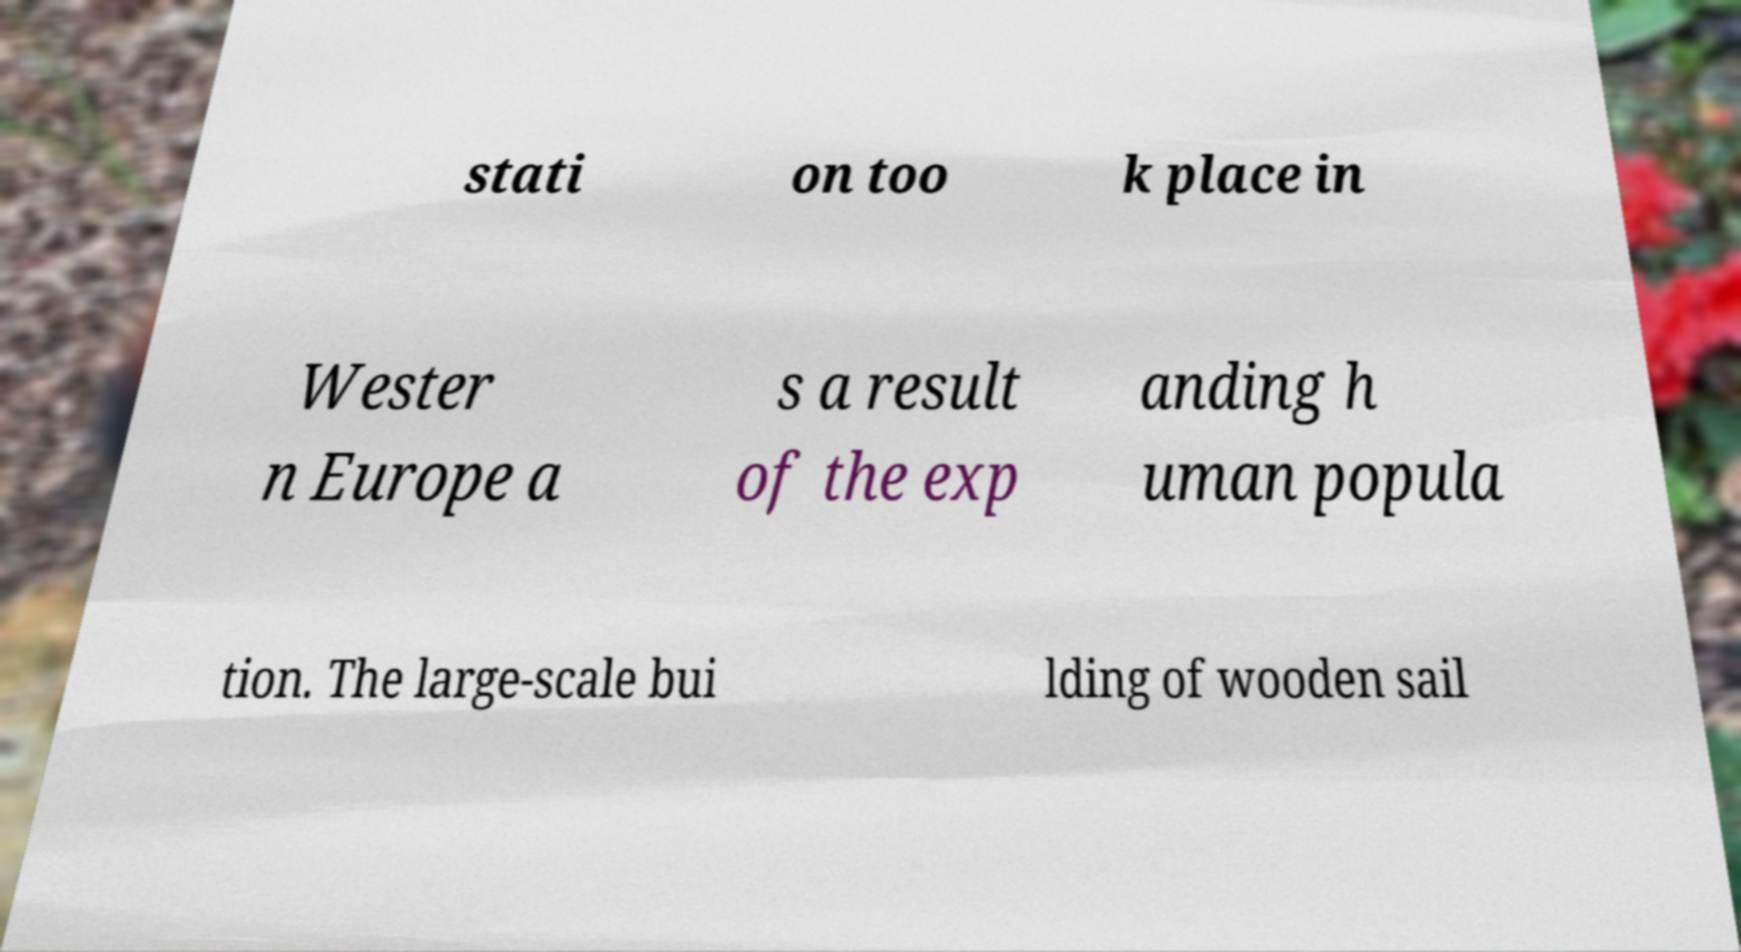For documentation purposes, I need the text within this image transcribed. Could you provide that? stati on too k place in Wester n Europe a s a result of the exp anding h uman popula tion. The large-scale bui lding of wooden sail 